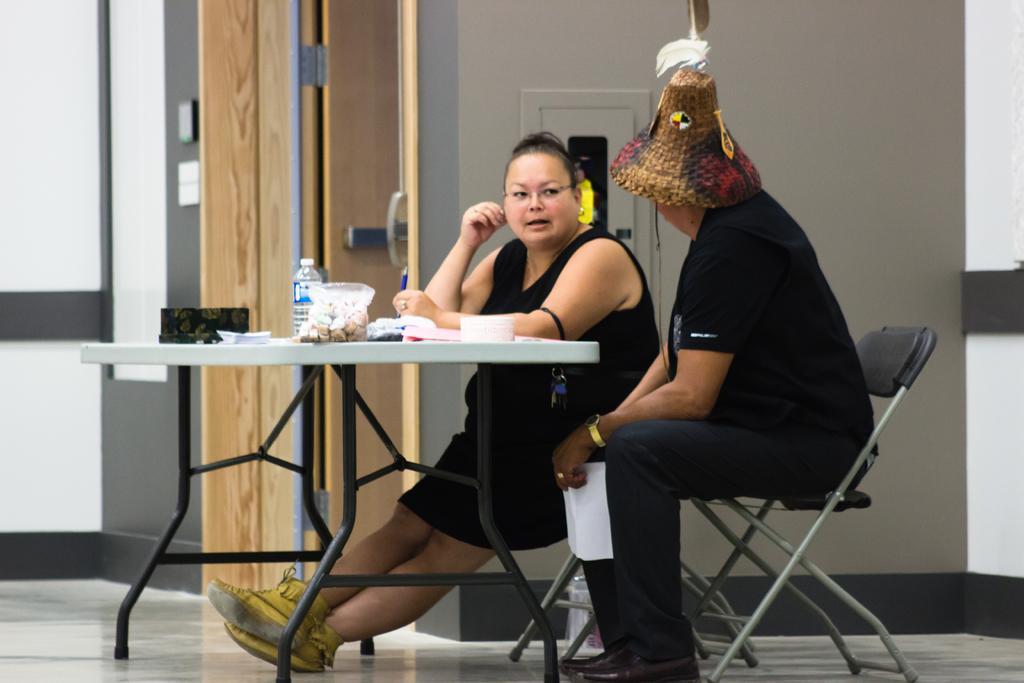Could you give a brief overview of what you see in this image? In the picture there is a table, in front of the table there are two persons sitting and talking to each other, on the table there are some snacks,water bottle and books in the background there is a door and white color wall. 